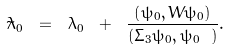Convert formula to latex. <formula><loc_0><loc_0><loc_500><loc_500>\tilde { \lambda } _ { 0 } \ = \ \lambda _ { 0 } \ + \ \frac { \left ( \psi _ { 0 } , W \psi _ { 0 } \right ) } { \left ( \Sigma _ { 3 } \psi _ { 0 } , \psi _ { 0 } \ \right ) } .</formula> 